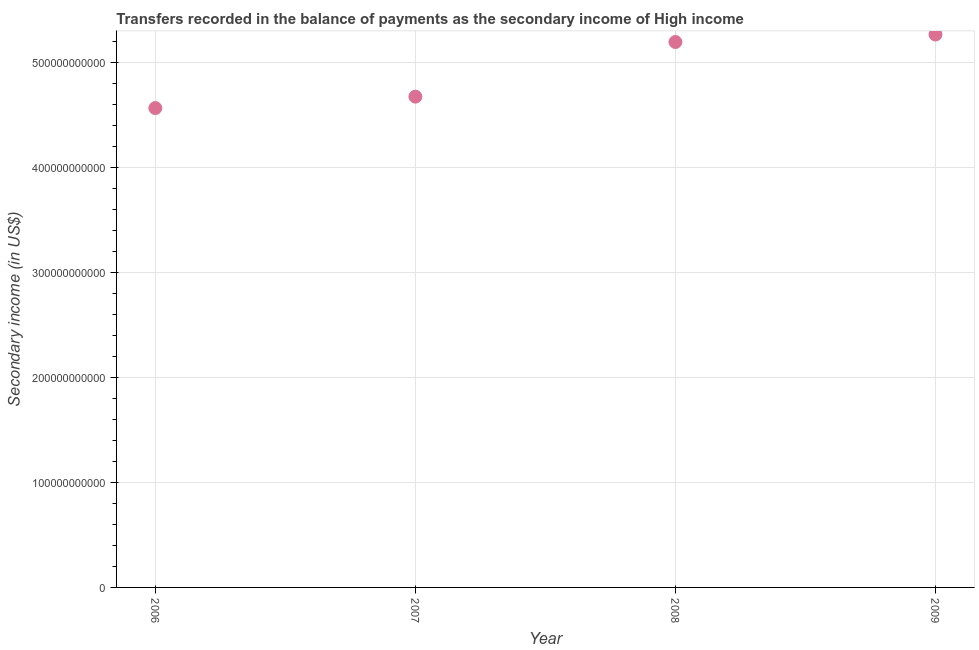What is the amount of secondary income in 2008?
Provide a succinct answer. 5.19e+11. Across all years, what is the maximum amount of secondary income?
Make the answer very short. 5.26e+11. Across all years, what is the minimum amount of secondary income?
Provide a succinct answer. 4.56e+11. What is the sum of the amount of secondary income?
Your answer should be compact. 1.97e+12. What is the difference between the amount of secondary income in 2007 and 2008?
Provide a short and direct response. -5.20e+1. What is the average amount of secondary income per year?
Ensure brevity in your answer.  4.92e+11. What is the median amount of secondary income?
Offer a terse response. 4.93e+11. What is the ratio of the amount of secondary income in 2007 to that in 2008?
Give a very brief answer. 0.9. What is the difference between the highest and the second highest amount of secondary income?
Provide a short and direct response. 7.14e+09. Is the sum of the amount of secondary income in 2007 and 2009 greater than the maximum amount of secondary income across all years?
Keep it short and to the point. Yes. What is the difference between the highest and the lowest amount of secondary income?
Your response must be concise. 7.00e+1. In how many years, is the amount of secondary income greater than the average amount of secondary income taken over all years?
Your answer should be very brief. 2. How many dotlines are there?
Provide a succinct answer. 1. How many years are there in the graph?
Offer a very short reply. 4. What is the difference between two consecutive major ticks on the Y-axis?
Your answer should be compact. 1.00e+11. Are the values on the major ticks of Y-axis written in scientific E-notation?
Ensure brevity in your answer.  No. Does the graph contain any zero values?
Provide a short and direct response. No. Does the graph contain grids?
Offer a terse response. Yes. What is the title of the graph?
Offer a very short reply. Transfers recorded in the balance of payments as the secondary income of High income. What is the label or title of the X-axis?
Make the answer very short. Year. What is the label or title of the Y-axis?
Give a very brief answer. Secondary income (in US$). What is the Secondary income (in US$) in 2006?
Provide a succinct answer. 4.56e+11. What is the Secondary income (in US$) in 2007?
Provide a short and direct response. 4.67e+11. What is the Secondary income (in US$) in 2008?
Provide a short and direct response. 5.19e+11. What is the Secondary income (in US$) in 2009?
Offer a very short reply. 5.26e+11. What is the difference between the Secondary income (in US$) in 2006 and 2007?
Keep it short and to the point. -1.09e+1. What is the difference between the Secondary income (in US$) in 2006 and 2008?
Your response must be concise. -6.29e+1. What is the difference between the Secondary income (in US$) in 2006 and 2009?
Ensure brevity in your answer.  -7.00e+1. What is the difference between the Secondary income (in US$) in 2007 and 2008?
Offer a very short reply. -5.20e+1. What is the difference between the Secondary income (in US$) in 2007 and 2009?
Ensure brevity in your answer.  -5.92e+1. What is the difference between the Secondary income (in US$) in 2008 and 2009?
Offer a very short reply. -7.14e+09. What is the ratio of the Secondary income (in US$) in 2006 to that in 2007?
Your answer should be compact. 0.98. What is the ratio of the Secondary income (in US$) in 2006 to that in 2008?
Provide a short and direct response. 0.88. What is the ratio of the Secondary income (in US$) in 2006 to that in 2009?
Your answer should be very brief. 0.87. What is the ratio of the Secondary income (in US$) in 2007 to that in 2009?
Offer a terse response. 0.89. What is the ratio of the Secondary income (in US$) in 2008 to that in 2009?
Your answer should be compact. 0.99. 